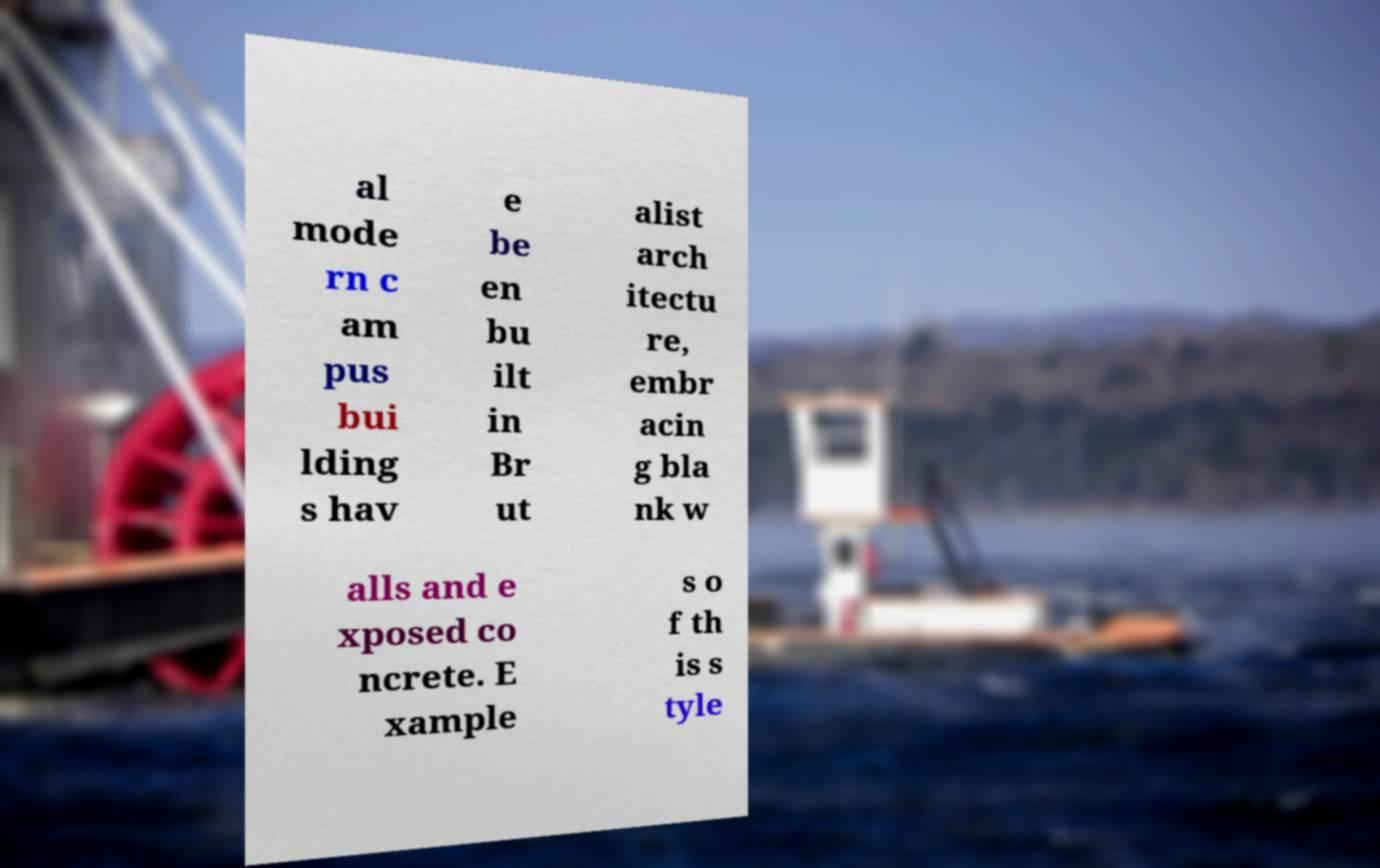Can you read and provide the text displayed in the image?This photo seems to have some interesting text. Can you extract and type it out for me? al mode rn c am pus bui lding s hav e be en bu ilt in Br ut alist arch itectu re, embr acin g bla nk w alls and e xposed co ncrete. E xample s o f th is s tyle 